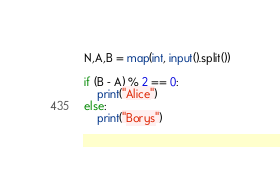Convert code to text. <code><loc_0><loc_0><loc_500><loc_500><_Python_>N,A,B = map(int, input().split())

if (B - A) % 2 == 0:
    print("Alice")
else:
    print("Borys")</code> 